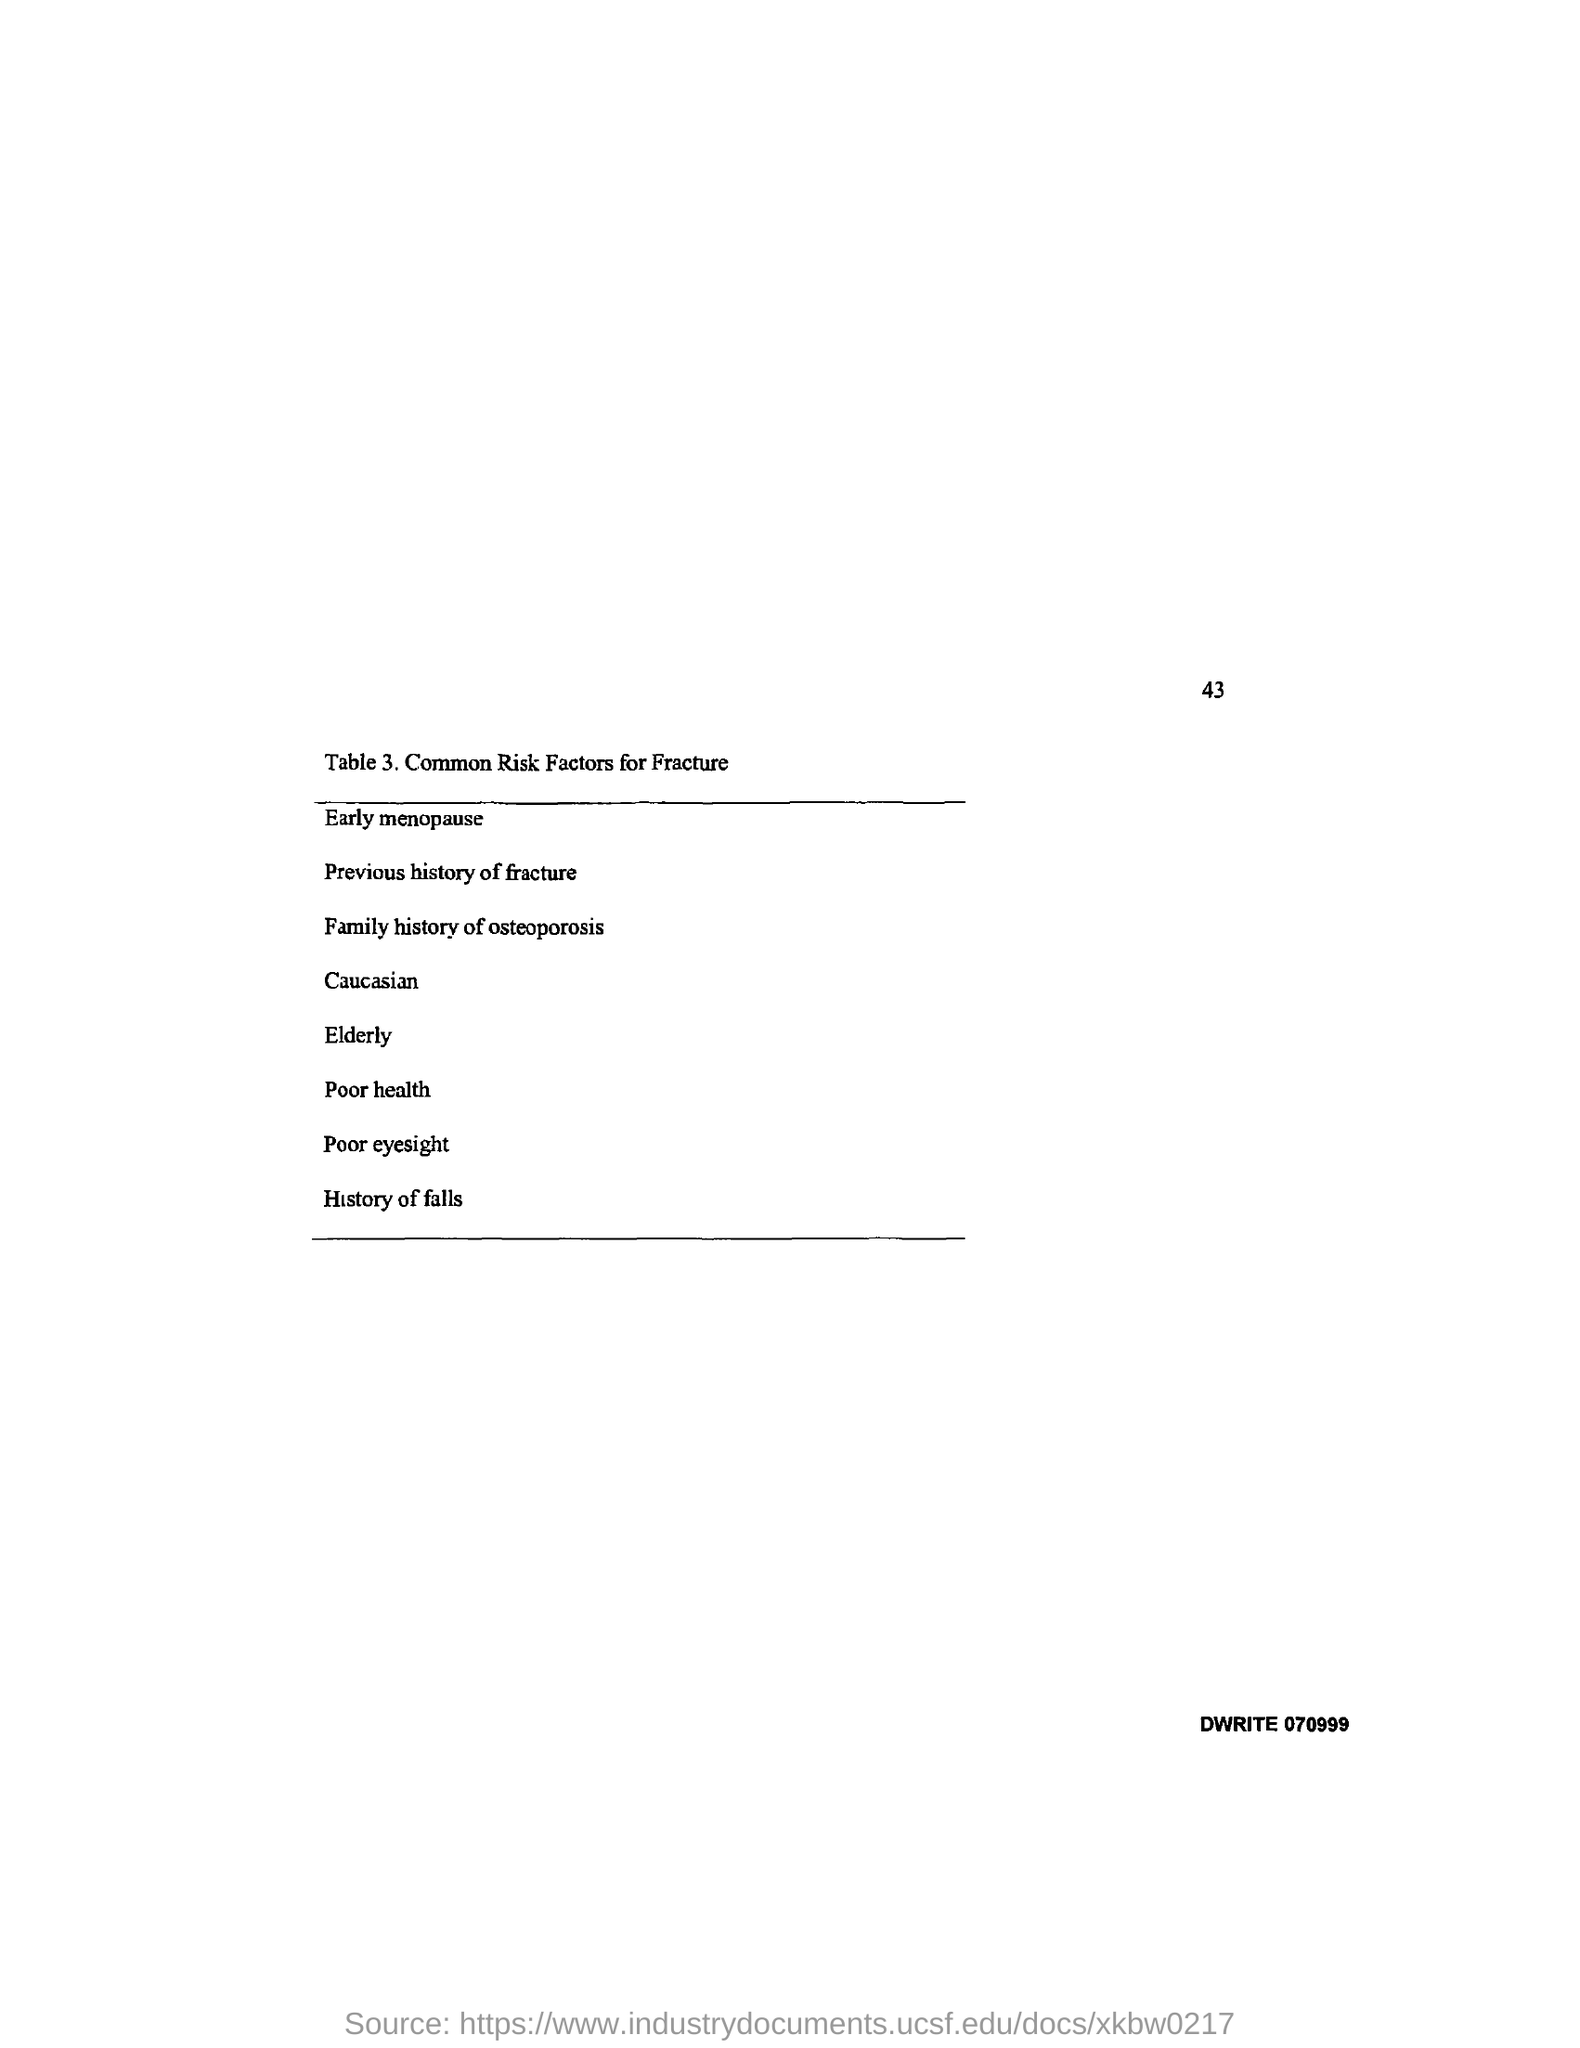Give some essential details in this illustration. Early menopause is the first risk factor for fracture mentioned in Table 3. The page number mentioned in this document is 43. Table 3 in this document describes common risk factors for fracture. The last risk factor for fracture mentioned in Table 3 is history of falls. 